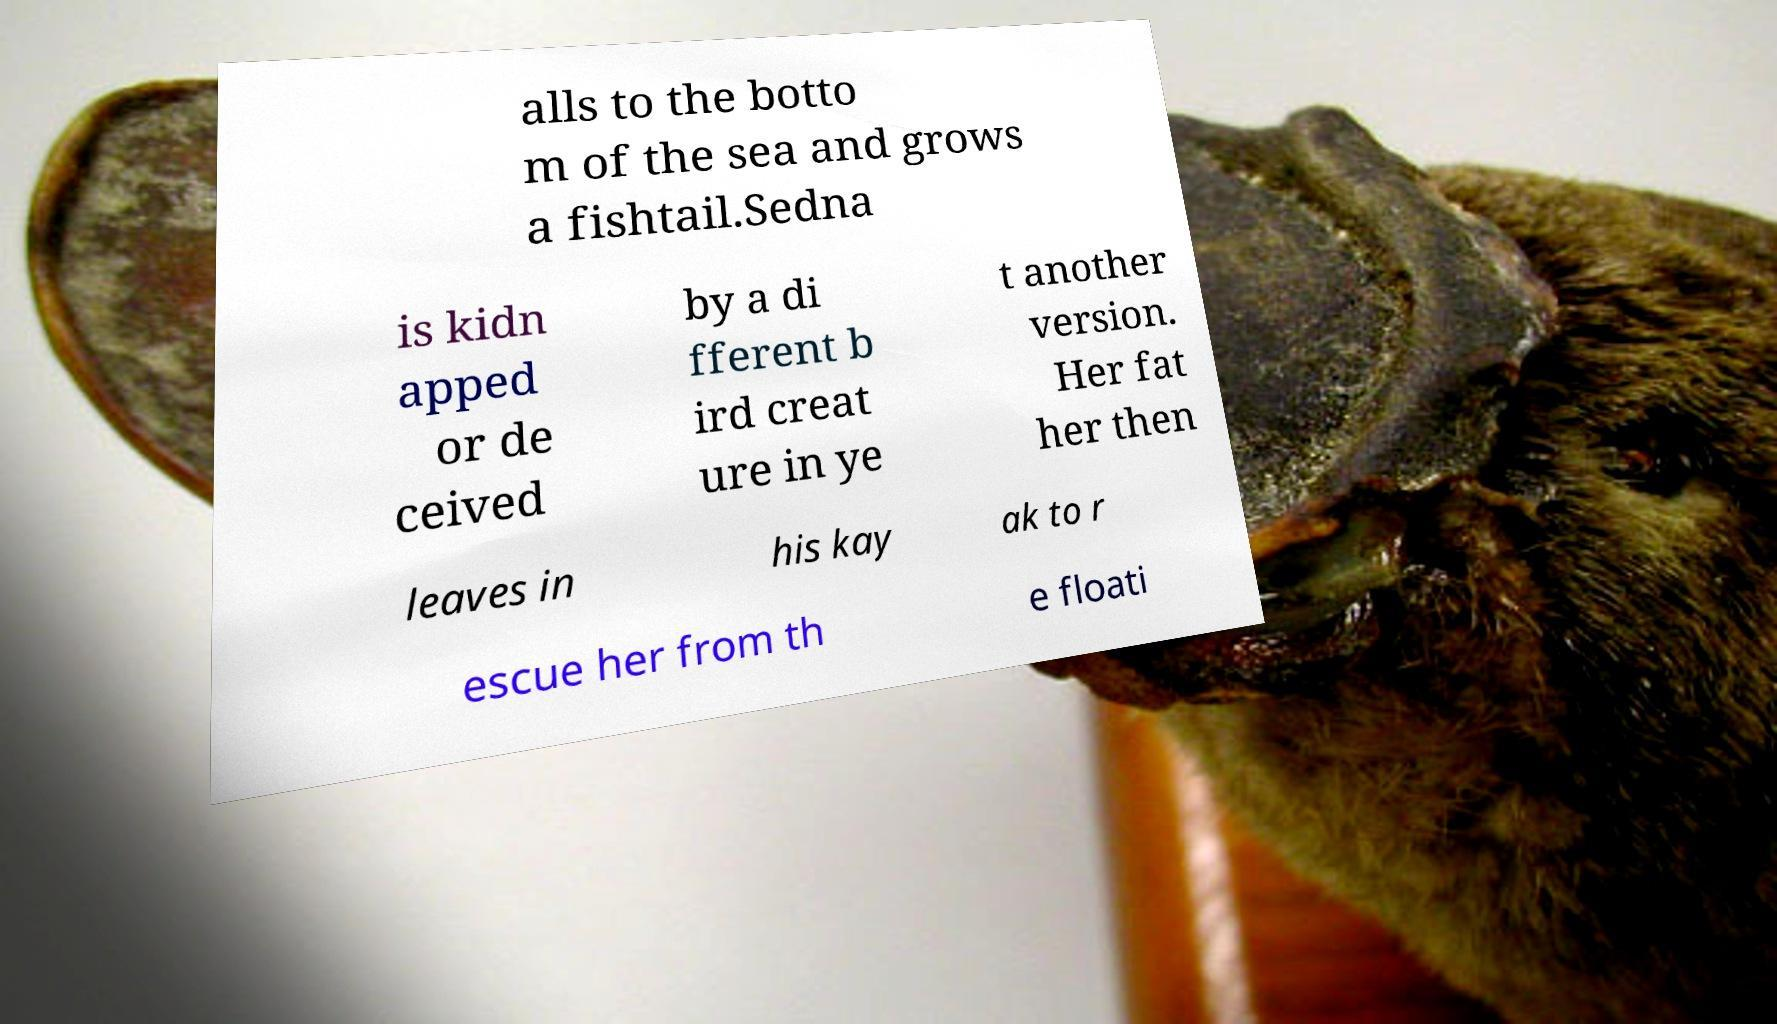Can you read and provide the text displayed in the image?This photo seems to have some interesting text. Can you extract and type it out for me? alls to the botto m of the sea and grows a fishtail.Sedna is kidn apped or de ceived by a di fferent b ird creat ure in ye t another version. Her fat her then leaves in his kay ak to r escue her from th e floati 